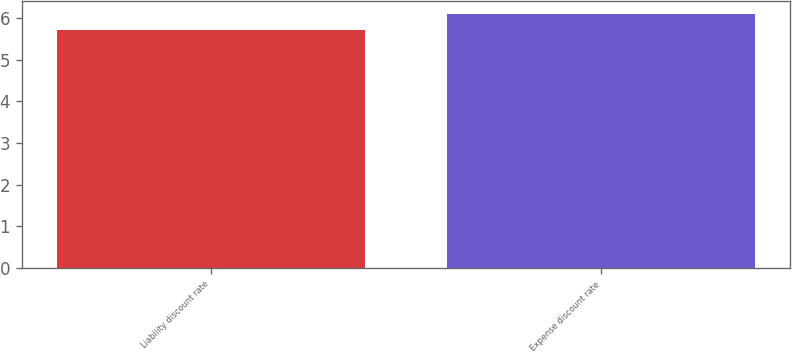Convert chart to OTSL. <chart><loc_0><loc_0><loc_500><loc_500><bar_chart><fcel>Liability discount rate<fcel>Expense discount rate<nl><fcel>5.7<fcel>6.1<nl></chart> 